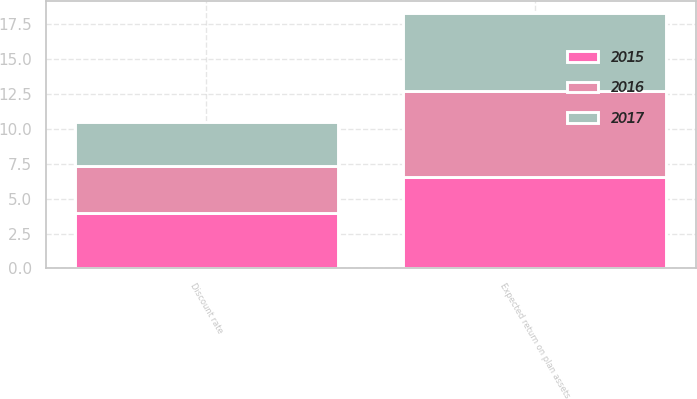Convert chart to OTSL. <chart><loc_0><loc_0><loc_500><loc_500><stacked_bar_chart><ecel><fcel>Discount rate<fcel>Expected return on plan assets<nl><fcel>2017<fcel>3.12<fcel>5.53<nl><fcel>2016<fcel>3.41<fcel>6.22<nl><fcel>2015<fcel>3.95<fcel>6.54<nl></chart> 